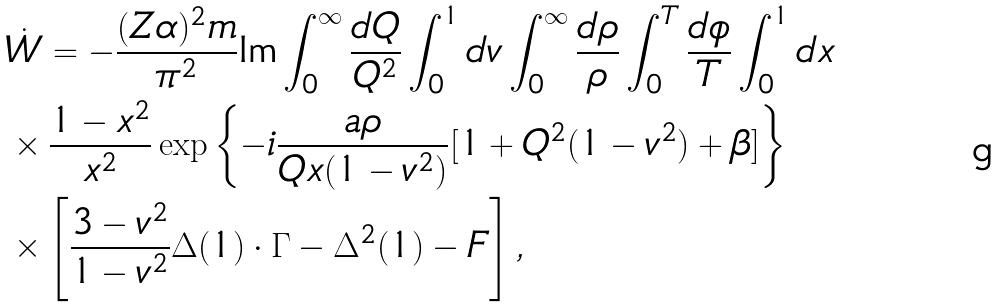<formula> <loc_0><loc_0><loc_500><loc_500>& \dot { W } = - \frac { ( Z \alpha ) ^ { 2 } m } { \pi ^ { 2 } } \text {Im} \int _ { 0 } ^ { \infty } \frac { d Q } { Q ^ { 2 } } \int _ { 0 } ^ { 1 } d v \int _ { 0 } ^ { \infty } \frac { d \rho } { \rho } \int _ { 0 } ^ { T } \frac { d \phi } { T } \int _ { 0 } ^ { 1 } d x \\ & \times \frac { 1 - x ^ { 2 } } { x ^ { 2 } } \exp \left \{ - i \frac { a \rho } { Q x ( 1 - v ^ { 2 } ) } [ 1 + Q ^ { 2 } ( 1 - v ^ { 2 } ) + \beta ] \right \} \\ & \times \left [ \frac { 3 - v ^ { 2 } } { 1 - v ^ { 2 } } \Delta ( 1 ) \cdot \Gamma - \Delta ^ { 2 } ( 1 ) - F \right ] ,</formula> 